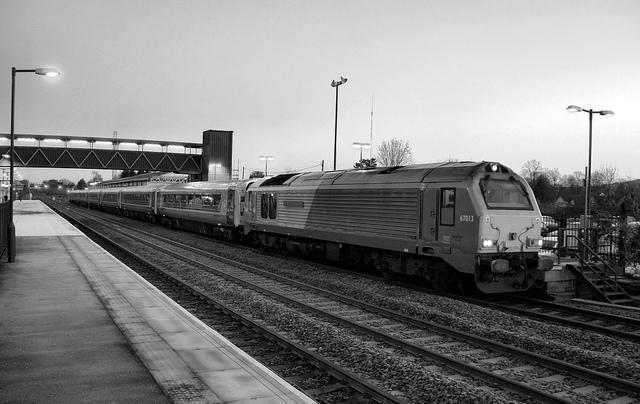How many engine cars are there before the light gray container car?
Give a very brief answer. 1. How many light poles do you see?
Give a very brief answer. 5. How many people are wearing a green shirt?
Give a very brief answer. 0. 